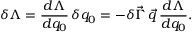<formula> <loc_0><loc_0><loc_500><loc_500>\delta \Lambda = \frac { d \Lambda } { d q _ { 0 } } \, \delta q _ { 0 } = - \delta \vec { \Gamma } \, \vec { q } \, \frac { d \Lambda } { d q _ { 0 } } .</formula> 